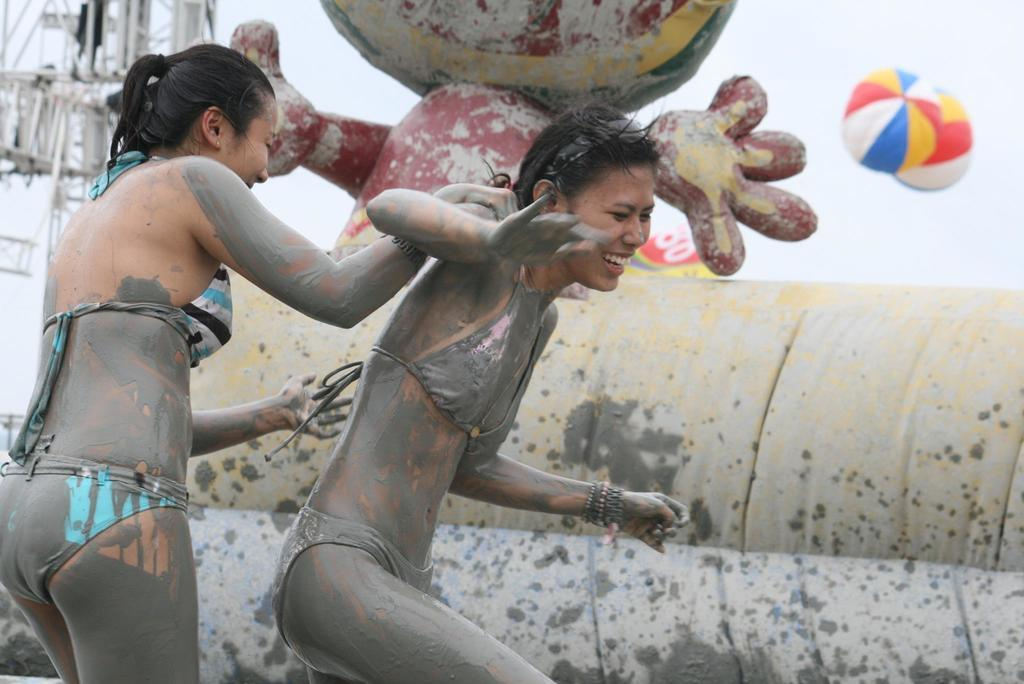How many people are in the image? There are two ladies in the image. What is behind the ladies? There is a wall behind the ladies. What can be seen behind the wall? There is a statue behind the wall. What other structures are visible in the background? There is a tower and parachutes in the background. What topics are being discussed by the committee in the image? There is no committee present in the image, so it is not possible to determine what topics might be discussed. 